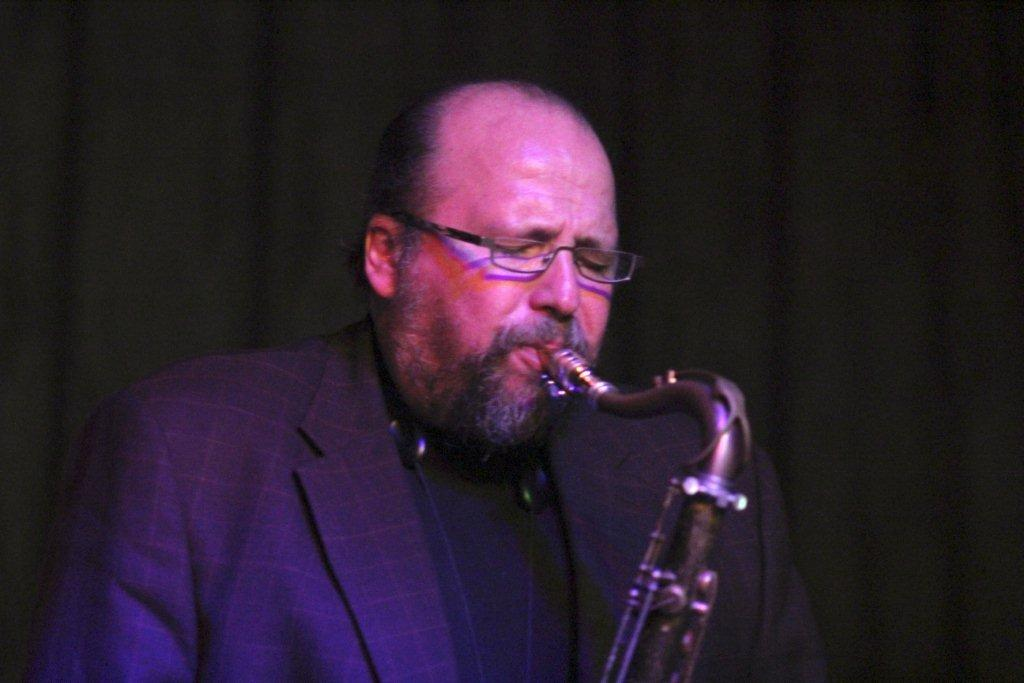What is the main subject of the image? The main subject of the image is a man. What is the man doing in the image? The man is playing a musical instrument in the image. Can you describe the background of the image? The background of the image is dark. How much money is the man holding in the image? There is no indication of money in the image; the man is playing a musical instrument. What type of wrist accessory is the man wearing in the image? There is no wrist accessory visible in the image. 